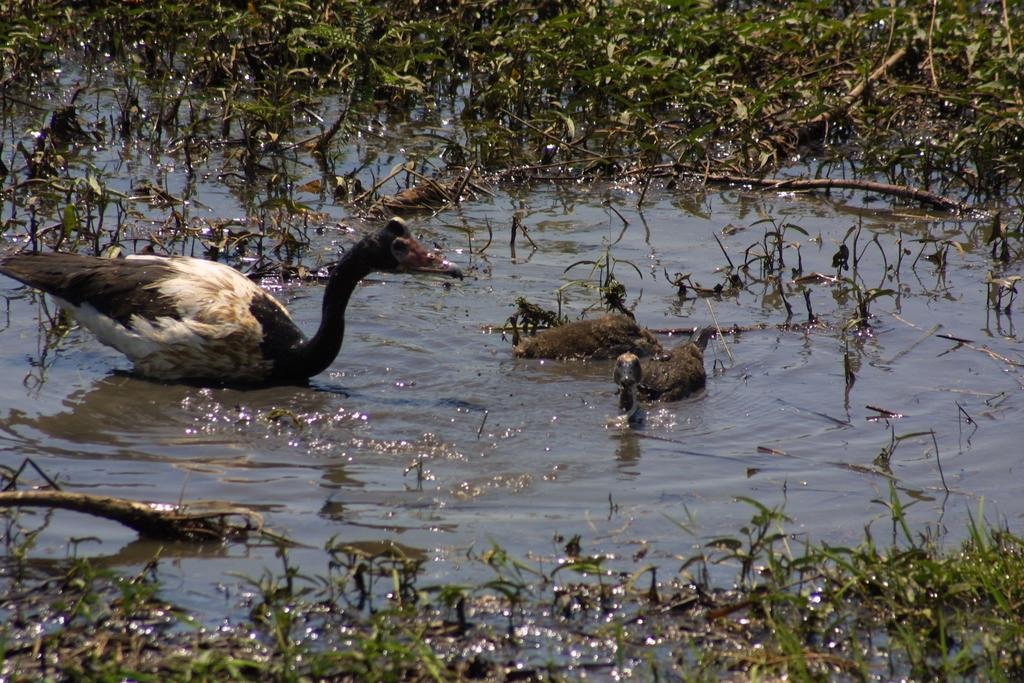What is the primary element in the image? There is water in the image. How many birds are in the water? There are three birds in the water. What type of vegetation can be seen in the image? There is grass visible in the image. What type of industry can be seen in the background of the image? There is no industry visible in the image; it primarily features water, birds, and grass. 